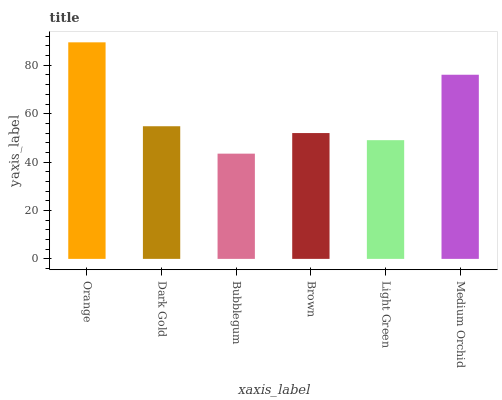Is Bubblegum the minimum?
Answer yes or no. Yes. Is Orange the maximum?
Answer yes or no. Yes. Is Dark Gold the minimum?
Answer yes or no. No. Is Dark Gold the maximum?
Answer yes or no. No. Is Orange greater than Dark Gold?
Answer yes or no. Yes. Is Dark Gold less than Orange?
Answer yes or no. Yes. Is Dark Gold greater than Orange?
Answer yes or no. No. Is Orange less than Dark Gold?
Answer yes or no. No. Is Dark Gold the high median?
Answer yes or no. Yes. Is Brown the low median?
Answer yes or no. Yes. Is Bubblegum the high median?
Answer yes or no. No. Is Dark Gold the low median?
Answer yes or no. No. 